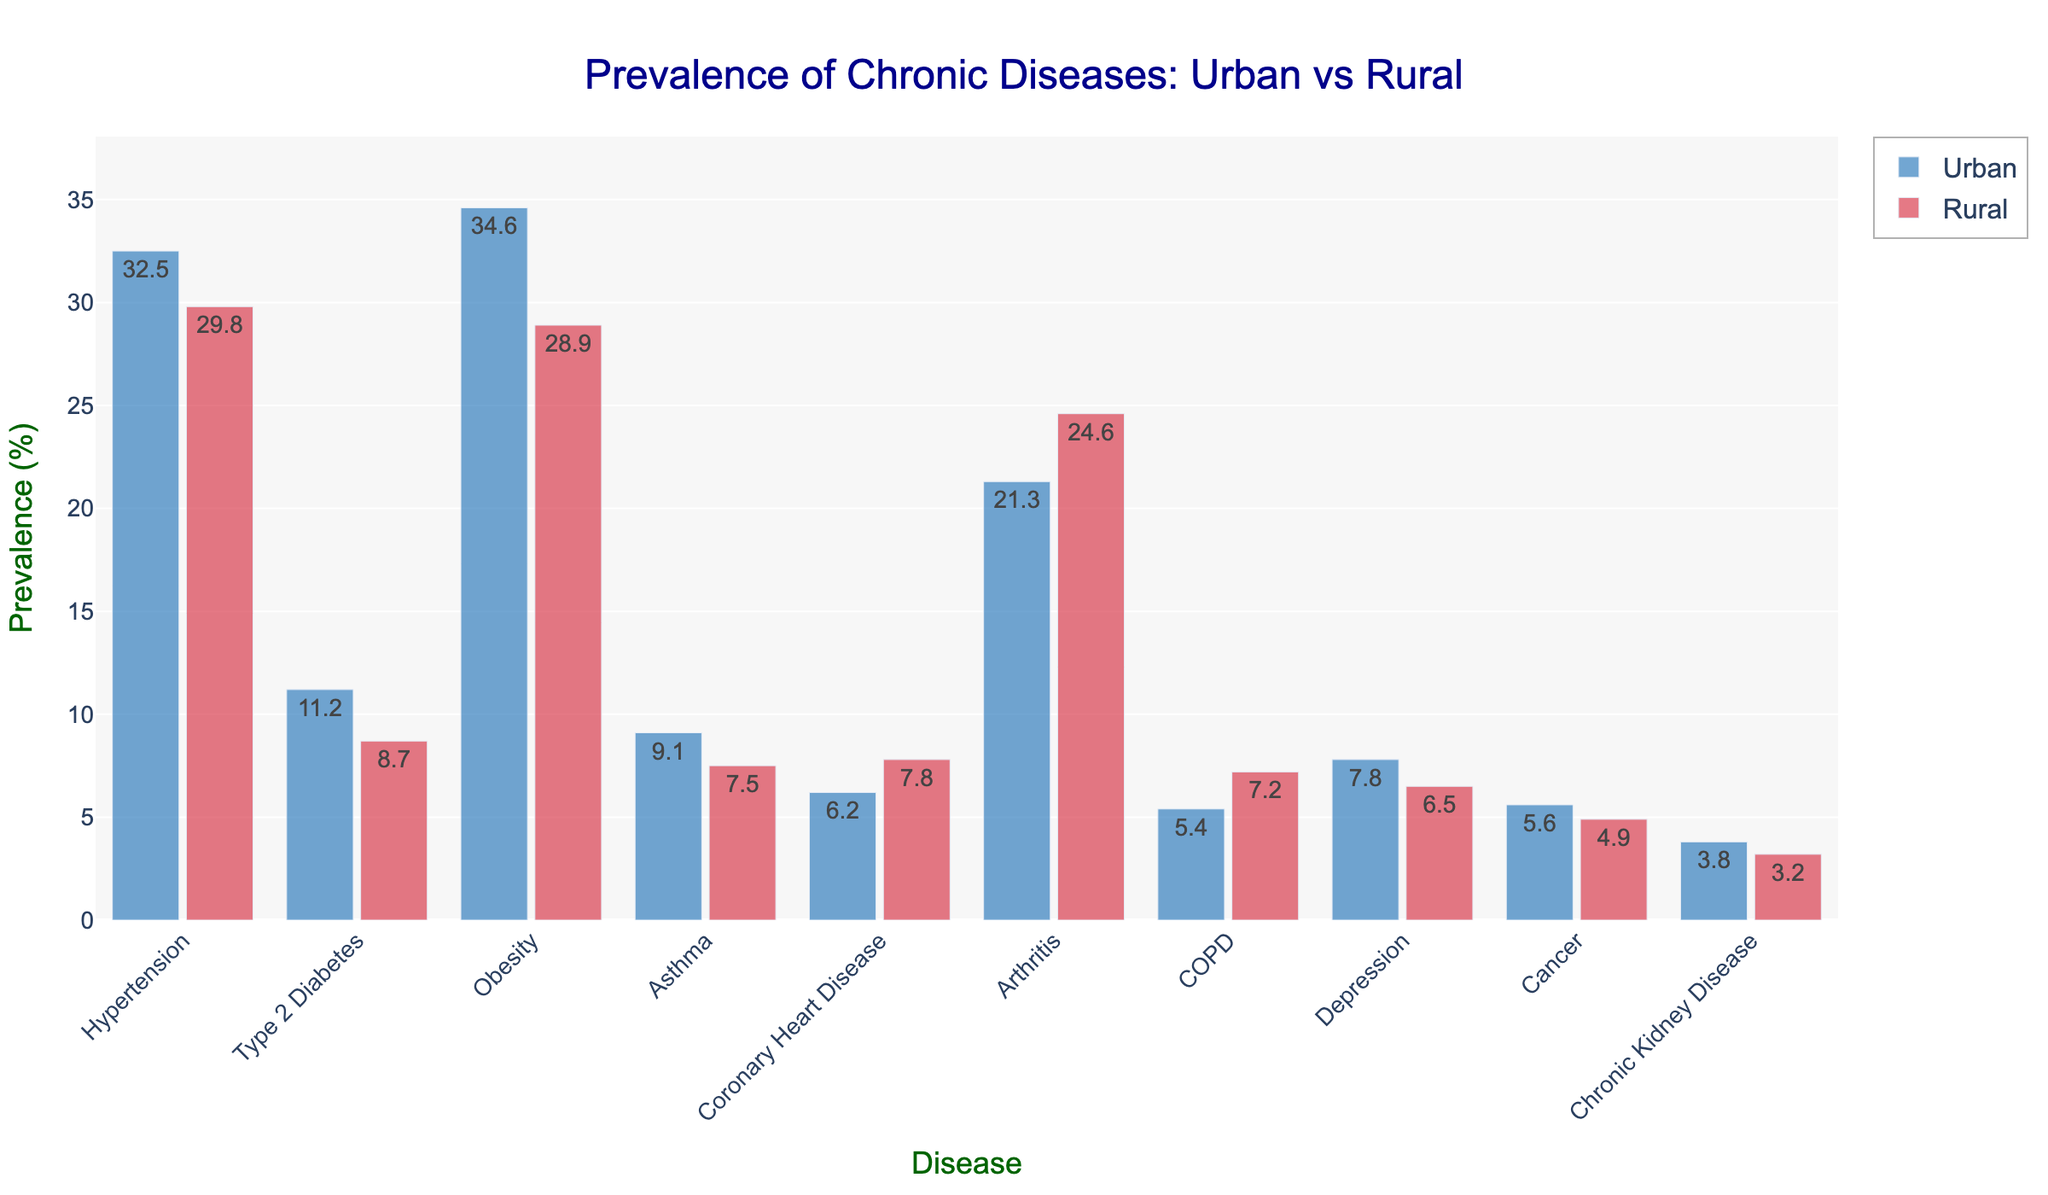Which chronic disease has the highest prevalence in urban populations? Look at the bar heights for each disease in the Urban category. The highest bar corresponds to Obesity.
Answer: Obesity Which chronic disease has the highest prevalence in rural populations? Look at the bar heights for each disease in the Rural category. The highest bar corresponds to Arthritis.
Answer: Arthritis What is the difference in prevalence between Urban and Rural populations for Hypertension? Subtract the prevalence of Hypertension in Rural from Urban: 32.5% - 29.8% = 2.7%
Answer: 2.7% For which disease is the prevalence higher in rural populations compared to urban populations? Compare each bar pair for Urban and Rural. For Coronary Heart Disease, Arthritis, and COPD, the Rural bars are higher.
Answer: Coronary Heart Disease, Arthritis, COPD What is the combined prevalence of Type 2 Diabetes and Asthma in Urban populations? Add the Urban prevalence rates for Type 2 Diabetes (11.2%) and Asthma (9.1%): 11.2% + 9.1% = 20.3%
Answer: 20.3% Which disease has a nearly equal prevalence in both Urban and Rural populations? Look for diseases where the Urban and Rural bars are at nearly the same height. Chronic Kidney Disease has prevalences of 3.8% and 3.2%, which are close.
Answer: Chronic Kidney Disease What is the average prevalence of Depression in both Urban and Rural populations? Add the Urban and Rural prevalence rates for Depression and divide by 2: (7.8% + 6.5%) / 2 = 7.15%
Answer: 7.15% How many diseases have a higher prevalence in Urban compared to Rural populations? Compare the prevalence rates of each disease in Urban and Rural. There are six diseases: Hypertension, Type 2 Diabetes, Obesity, Asthma, Depression, and Cancer.
Answer: 6 For which disease is the difference in prevalence between Urban and Rural populations the greatest? Calculate differences for each disease and compare: 34.6% (Obesity in Urban) - 28.9% (Obesity in Rural) = 5.7% is the greatest difference.
Answer: Obesity What is the sum of the Urban prevalence rates for Cancer and Chronic Kidney Disease? Add the Urban prevalence rates for Cancer (5.6%) and Chronic Kidney Disease (3.8%): 5.6% + 3.8% = 9.4%
Answer: 9.4% 